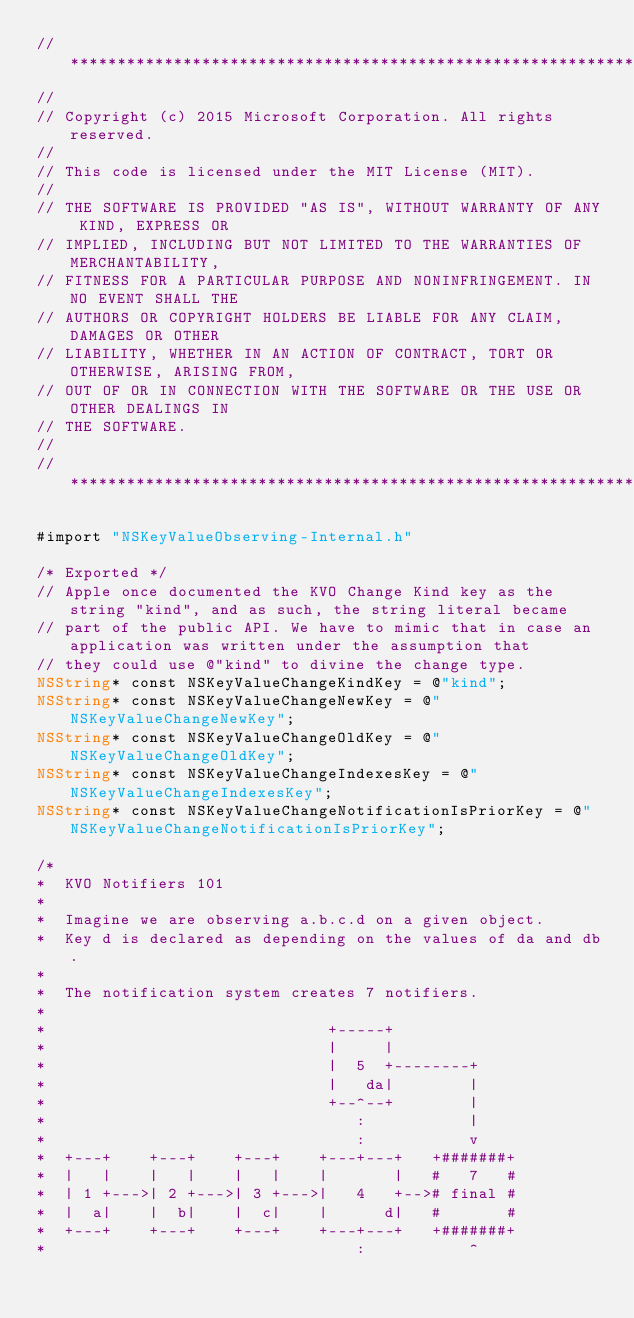<code> <loc_0><loc_0><loc_500><loc_500><_ObjectiveC_>//******************************************************************************
//
// Copyright (c) 2015 Microsoft Corporation. All rights reserved.
//
// This code is licensed under the MIT License (MIT).
//
// THE SOFTWARE IS PROVIDED "AS IS", WITHOUT WARRANTY OF ANY KIND, EXPRESS OR
// IMPLIED, INCLUDING BUT NOT LIMITED TO THE WARRANTIES OF MERCHANTABILITY,
// FITNESS FOR A PARTICULAR PURPOSE AND NONINFRINGEMENT. IN NO EVENT SHALL THE
// AUTHORS OR COPYRIGHT HOLDERS BE LIABLE FOR ANY CLAIM, DAMAGES OR OTHER
// LIABILITY, WHETHER IN AN ACTION OF CONTRACT, TORT OR OTHERWISE, ARISING FROM,
// OUT OF OR IN CONNECTION WITH THE SOFTWARE OR THE USE OR OTHER DEALINGS IN
// THE SOFTWARE.
//
//******************************************************************************

#import "NSKeyValueObserving-Internal.h"

/* Exported */
// Apple once documented the KVO Change Kind key as the string "kind", and as such, the string literal became
// part of the public API. We have to mimic that in case an application was written under the assumption that
// they could use @"kind" to divine the change type.
NSString* const NSKeyValueChangeKindKey = @"kind";
NSString* const NSKeyValueChangeNewKey = @"NSKeyValueChangeNewKey";
NSString* const NSKeyValueChangeOldKey = @"NSKeyValueChangeOldKey";
NSString* const NSKeyValueChangeIndexesKey = @"NSKeyValueChangeIndexesKey";
NSString* const NSKeyValueChangeNotificationIsPriorKey = @"NSKeyValueChangeNotificationIsPriorKey";

/*
*  KVO Notifiers 101
*
*  Imagine we are observing a.b.c.d on a given object.
*  Key d is declared as depending on the values of da and db.
*
*  The notification system creates 7 notifiers.
*
*                              +-----+
*                              |     |
*                              |  5  +--------+
*                              |   da|        |
*                              +--^--+        |
*                                 :           |
*                                 :           v
*  +---+    +---+    +---+    +---+---+   +#######+
*  |   |    |   |    |   |    |       |   #   7   #
*  | 1 +--->| 2 +--->| 3 +--->|   4   +--># final #
*  |  a|    |  b|    |  c|    |      d|   #       #
*  +---+    +---+    +---+    +---+---+   +#######+
*                                 :           ^</code> 